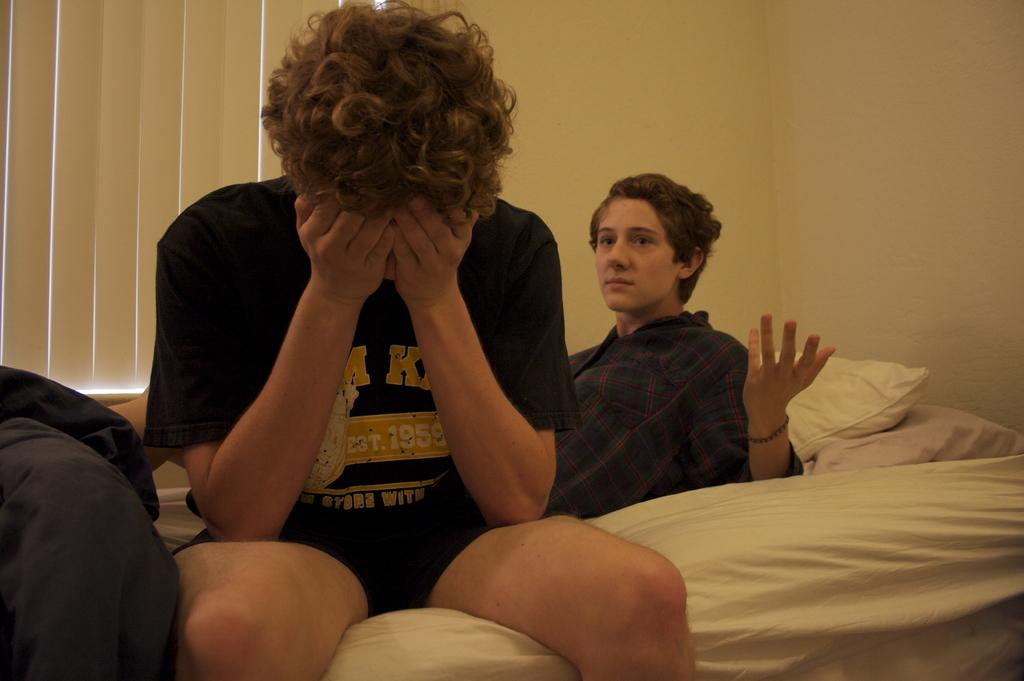How many people are in the image? There are two persons in the image. What are the positions of the two people in the image? One person is lying on the cot, and the other person is sitting on the cot. What can be seen in the background of the image? There are blankets, blinds, and walls in the background of the image. What type of bird can be seen smashing a desk in the image? There is no bird or desk present in the image, and therefore no such activity can be observed. 